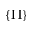<formula> <loc_0><loc_0><loc_500><loc_500>\{ \Pi \}</formula> 